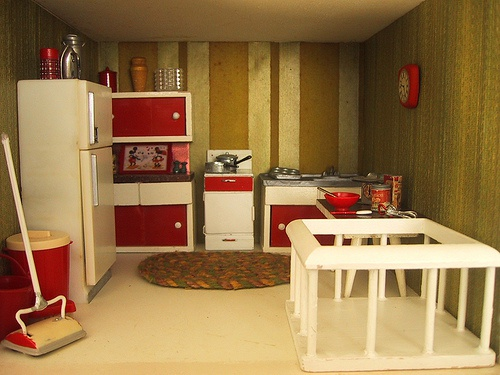Describe the objects in this image and their specific colors. I can see refrigerator in black, tan, and olive tones, oven in black, tan, and brown tones, bottle in black and gray tones, bottle in black, maroon, and brown tones, and bowl in black, brown, red, maroon, and tan tones in this image. 